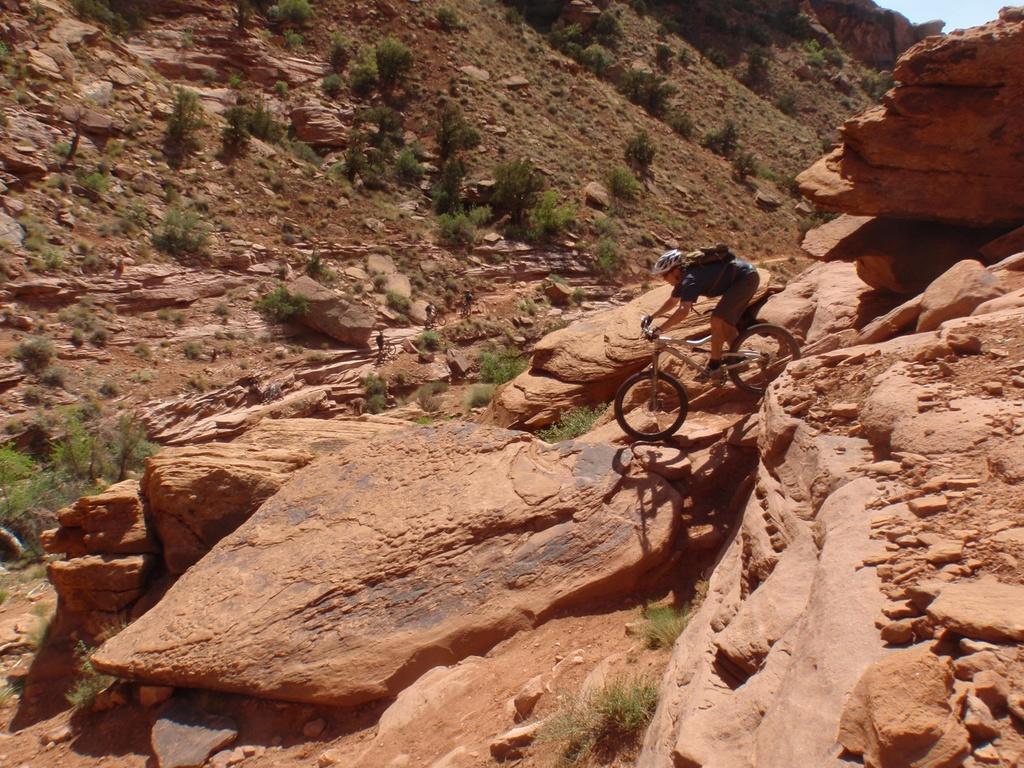Describe this image in one or two sentences. In the picture we can see a hill with rocks and on it we can see a person riding a bicycle, he is wearing a helmet and a bag and in front of him we can see a hill slope with some plants and rocks and on the top of it we can see a part of the sky. 